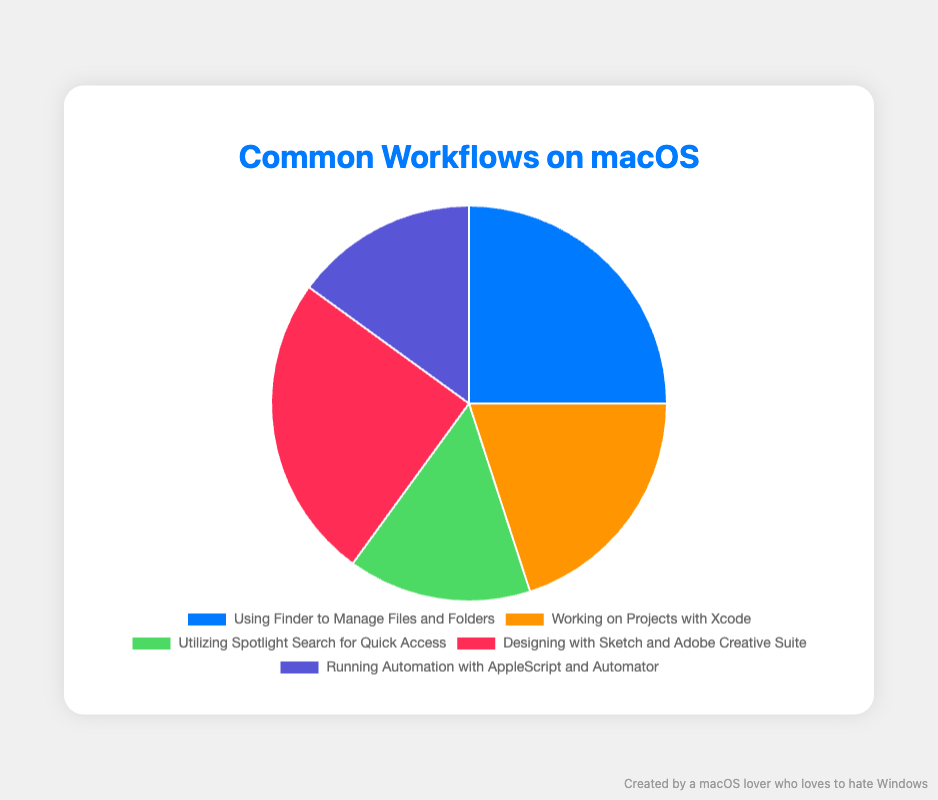what is the most common workflow on macOS? The chart shows that the most common workflows, each accounting for 25% of the total, are "Using Finder to Manage Files and Folders" and "Designing with Sketch and Adobe Creative Suite". Therefore, these two activities are equally the most common.
Answer: Using Finder to Manage Files and Folders and Designing with Sketch and Adobe Creative Suite Which workflow has the smallest share of usage? By examining the percentages given in the chart, the workflows "Utilizing Spotlight Search for Quick Access" and "Running Automation with AppleScript and Automator" both make up 15% each, which is the smallest share among the listed workflows.
Answer: Utilizing Spotlight Search for Quick Access and Running Automation with AppleScript and Automator How does the percentage of working on projects with Xcode compare to using Finder to manage files and folders? The chart indicates that "Working on Projects with Xcode" accounts for 20% while "Using Finder to Manage Files and Folders" accounts for 25%. Therefore, using Finder to manage files and folders is more common by a margin of 5%.
Answer: Using Finder to Manage Files and Folders is 5% more common What percentage of workflows involve designing tools like Sketch and Adobe Creative Suite combined with Xcode usage? By summing the percentages for "Designing with Sketch and Adobe Creative Suite" (25%) and "Working on Projects with Xcode" (20%), the total is 45%.
Answer: 45% Which color represents running automation with AppleScript and Automator in the pie chart? The portion of the pie chart representing "Running Automation with AppleScript and Automator" is colored purple.
Answer: Purple How do the totals for designing with Sketch and Adobe Creative Suite and utilizing Spotlight Search for quick access compare to managing files and folders with Finder? The sum of "Designing with Sketch and Adobe Creative Suite" (25%) and "Utilizing Spotlight Search for Quick Access" (15%) is 40%, which is 15% more than the 25% for "Using Finder to Manage Files and Folders".
Answer: 40% compared to 25% What is the difference in percentage points between the most common and least common workflows? The most common workflows each have 25% and the least common have 15%. The difference is thus 25% - 15% = 10%.
Answer: 10% What combined percentage of workflows is devoted to automation and quick access tools on macOS? The combined percentage for "Utilizing Spotlight Search for Quick Access" (15%) and "Running Automation with AppleScript and Automator" (15%) is 30%.
Answer: 30% 